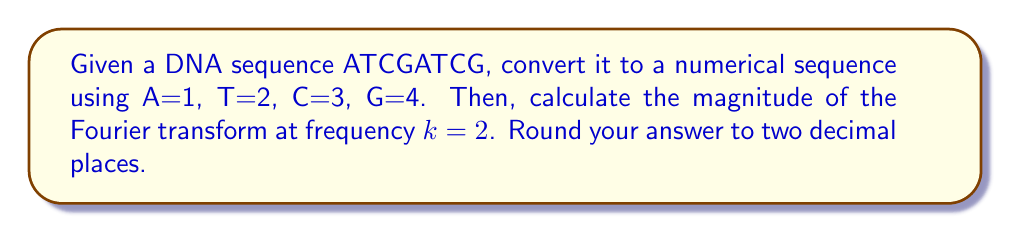Show me your answer to this math problem. 1) Convert the DNA sequence to numerical values:
   ATCGATCG → 12341234

2) Let $x[n]$ be our numerical sequence. We need to calculate:

   $$X[k] = \sum_{n=0}^{N-1} x[n]e^{-i2\pi kn/N}$$

   where $N=8$ (length of the sequence) and $k=2$.

3) Expand the sum:

   $$X[2] = 1e^{-i2\pi(2)(0)/8} + 2e^{-i2\pi(2)(1)/8} + 3e^{-i2\pi(2)(2)/8} + 4e^{-i2\pi(2)(3)/8} + $$
   $$1e^{-i2\pi(2)(4)/8} + 2e^{-i2\pi(2)(5)/8} + 3e^{-i2\pi(2)(6)/8} + 4e^{-i2\pi(2)(7)/8}$$

4) Simplify the exponents:

   $$X[2] = 1 + 2e^{-i\pi/2} + 3e^{-i\pi} + 4e^{-i3\pi/2} + 1e^{-i2\pi} + 2e^{-i5\pi/2} + 3e^{-i3\pi} + 4e^{-i7\pi/2}$$

5) Evaluate the complex exponentials:

   $$X[2] = 1 + 2(-i) + 3(-1) + 4(i) + 1 + 2(-i) + 3(-1) + 4(i)$$

6) Combine like terms:

   $$X[2] = 2 - 6 + 8i - 4i = -4 + 4i$$

7) Calculate the magnitude:

   $$|X[2]| = \sqrt{(-4)^2 + 4^2} = \sqrt{32} = 4\sqrt{2} \approx 5.66$$

8) Rounding to two decimal places: 5.66
Answer: 5.66 